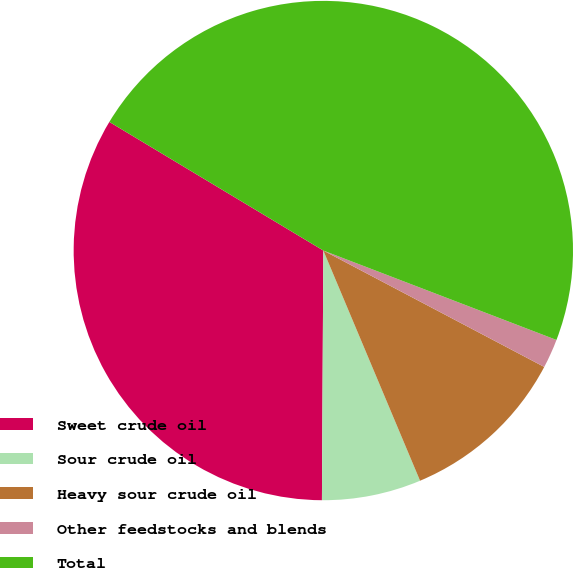<chart> <loc_0><loc_0><loc_500><loc_500><pie_chart><fcel>Sweet crude oil<fcel>Sour crude oil<fcel>Heavy sour crude oil<fcel>Other feedstocks and blends<fcel>Total<nl><fcel>33.52%<fcel>6.42%<fcel>10.95%<fcel>1.89%<fcel>47.21%<nl></chart> 